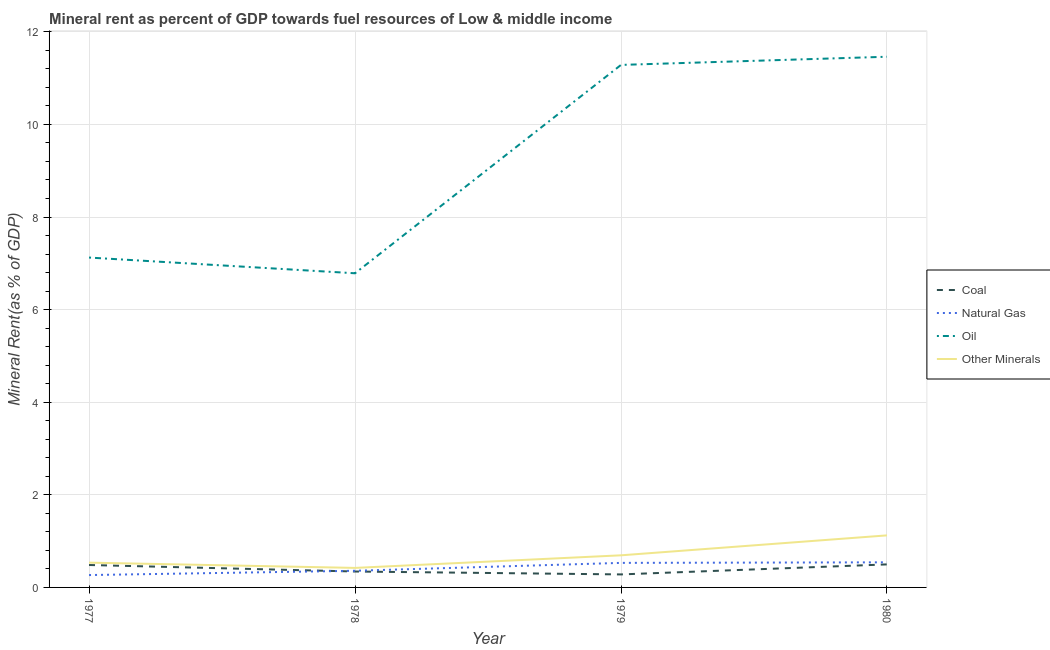How many different coloured lines are there?
Provide a short and direct response. 4. Does the line corresponding to coal rent intersect with the line corresponding to oil rent?
Your response must be concise. No. What is the natural gas rent in 1980?
Offer a very short reply. 0.54. Across all years, what is the maximum oil rent?
Your response must be concise. 11.46. Across all years, what is the minimum coal rent?
Give a very brief answer. 0.28. In which year was the coal rent minimum?
Ensure brevity in your answer.  1979. What is the total coal rent in the graph?
Your answer should be very brief. 1.61. What is the difference between the oil rent in 1977 and that in 1979?
Make the answer very short. -4.16. What is the difference between the coal rent in 1978 and the natural gas rent in 1977?
Give a very brief answer. 0.08. What is the average coal rent per year?
Your answer should be very brief. 0.4. In the year 1979, what is the difference between the natural gas rent and  rent of other minerals?
Ensure brevity in your answer.  -0.16. In how many years, is the natural gas rent greater than 0.4 %?
Offer a terse response. 2. What is the ratio of the coal rent in 1977 to that in 1978?
Give a very brief answer. 1.41. Is the difference between the oil rent in 1977 and 1979 greater than the difference between the natural gas rent in 1977 and 1979?
Make the answer very short. No. What is the difference between the highest and the second highest  rent of other minerals?
Offer a very short reply. 0.43. What is the difference between the highest and the lowest oil rent?
Make the answer very short. 4.68. In how many years, is the oil rent greater than the average oil rent taken over all years?
Offer a terse response. 2. Is it the case that in every year, the sum of the natural gas rent and  rent of other minerals is greater than the sum of coal rent and oil rent?
Make the answer very short. No. Does the  rent of other minerals monotonically increase over the years?
Ensure brevity in your answer.  No. Is the oil rent strictly greater than the coal rent over the years?
Keep it short and to the point. Yes. How many lines are there?
Provide a short and direct response. 4. How many years are there in the graph?
Offer a terse response. 4. Are the values on the major ticks of Y-axis written in scientific E-notation?
Provide a succinct answer. No. Does the graph contain grids?
Keep it short and to the point. Yes. What is the title of the graph?
Offer a very short reply. Mineral rent as percent of GDP towards fuel resources of Low & middle income. What is the label or title of the X-axis?
Offer a very short reply. Year. What is the label or title of the Y-axis?
Your response must be concise. Mineral Rent(as % of GDP). What is the Mineral Rent(as % of GDP) of Coal in 1977?
Give a very brief answer. 0.48. What is the Mineral Rent(as % of GDP) of Natural Gas in 1977?
Provide a short and direct response. 0.27. What is the Mineral Rent(as % of GDP) in Oil in 1977?
Your answer should be compact. 7.12. What is the Mineral Rent(as % of GDP) in Other Minerals in 1977?
Your response must be concise. 0.54. What is the Mineral Rent(as % of GDP) in Coal in 1978?
Your response must be concise. 0.34. What is the Mineral Rent(as % of GDP) in Natural Gas in 1978?
Offer a very short reply. 0.36. What is the Mineral Rent(as % of GDP) in Oil in 1978?
Your response must be concise. 6.79. What is the Mineral Rent(as % of GDP) of Other Minerals in 1978?
Your response must be concise. 0.42. What is the Mineral Rent(as % of GDP) of Coal in 1979?
Your response must be concise. 0.28. What is the Mineral Rent(as % of GDP) of Natural Gas in 1979?
Give a very brief answer. 0.53. What is the Mineral Rent(as % of GDP) in Oil in 1979?
Offer a terse response. 11.29. What is the Mineral Rent(as % of GDP) in Other Minerals in 1979?
Ensure brevity in your answer.  0.69. What is the Mineral Rent(as % of GDP) of Coal in 1980?
Your answer should be compact. 0.5. What is the Mineral Rent(as % of GDP) in Natural Gas in 1980?
Ensure brevity in your answer.  0.54. What is the Mineral Rent(as % of GDP) in Oil in 1980?
Offer a terse response. 11.46. What is the Mineral Rent(as % of GDP) of Other Minerals in 1980?
Provide a succinct answer. 1.12. Across all years, what is the maximum Mineral Rent(as % of GDP) in Coal?
Keep it short and to the point. 0.5. Across all years, what is the maximum Mineral Rent(as % of GDP) in Natural Gas?
Offer a very short reply. 0.54. Across all years, what is the maximum Mineral Rent(as % of GDP) of Oil?
Keep it short and to the point. 11.46. Across all years, what is the maximum Mineral Rent(as % of GDP) of Other Minerals?
Your response must be concise. 1.12. Across all years, what is the minimum Mineral Rent(as % of GDP) of Coal?
Your answer should be compact. 0.28. Across all years, what is the minimum Mineral Rent(as % of GDP) of Natural Gas?
Provide a short and direct response. 0.27. Across all years, what is the minimum Mineral Rent(as % of GDP) of Oil?
Offer a terse response. 6.79. Across all years, what is the minimum Mineral Rent(as % of GDP) of Other Minerals?
Give a very brief answer. 0.42. What is the total Mineral Rent(as % of GDP) in Coal in the graph?
Give a very brief answer. 1.61. What is the total Mineral Rent(as % of GDP) of Natural Gas in the graph?
Make the answer very short. 1.7. What is the total Mineral Rent(as % of GDP) of Oil in the graph?
Ensure brevity in your answer.  36.66. What is the total Mineral Rent(as % of GDP) in Other Minerals in the graph?
Offer a terse response. 2.77. What is the difference between the Mineral Rent(as % of GDP) of Coal in 1977 and that in 1978?
Keep it short and to the point. 0.14. What is the difference between the Mineral Rent(as % of GDP) of Natural Gas in 1977 and that in 1978?
Provide a short and direct response. -0.09. What is the difference between the Mineral Rent(as % of GDP) in Oil in 1977 and that in 1978?
Make the answer very short. 0.34. What is the difference between the Mineral Rent(as % of GDP) of Other Minerals in 1977 and that in 1978?
Your answer should be compact. 0.11. What is the difference between the Mineral Rent(as % of GDP) of Coal in 1977 and that in 1979?
Offer a terse response. 0.2. What is the difference between the Mineral Rent(as % of GDP) in Natural Gas in 1977 and that in 1979?
Make the answer very short. -0.26. What is the difference between the Mineral Rent(as % of GDP) of Oil in 1977 and that in 1979?
Ensure brevity in your answer.  -4.16. What is the difference between the Mineral Rent(as % of GDP) in Other Minerals in 1977 and that in 1979?
Offer a terse response. -0.16. What is the difference between the Mineral Rent(as % of GDP) in Coal in 1977 and that in 1980?
Provide a short and direct response. -0.01. What is the difference between the Mineral Rent(as % of GDP) of Natural Gas in 1977 and that in 1980?
Ensure brevity in your answer.  -0.28. What is the difference between the Mineral Rent(as % of GDP) of Oil in 1977 and that in 1980?
Keep it short and to the point. -4.34. What is the difference between the Mineral Rent(as % of GDP) of Other Minerals in 1977 and that in 1980?
Your answer should be compact. -0.59. What is the difference between the Mineral Rent(as % of GDP) in Coal in 1978 and that in 1979?
Offer a terse response. 0.06. What is the difference between the Mineral Rent(as % of GDP) in Natural Gas in 1978 and that in 1979?
Offer a very short reply. -0.17. What is the difference between the Mineral Rent(as % of GDP) in Oil in 1978 and that in 1979?
Ensure brevity in your answer.  -4.5. What is the difference between the Mineral Rent(as % of GDP) of Other Minerals in 1978 and that in 1979?
Keep it short and to the point. -0.27. What is the difference between the Mineral Rent(as % of GDP) of Coal in 1978 and that in 1980?
Keep it short and to the point. -0.15. What is the difference between the Mineral Rent(as % of GDP) of Natural Gas in 1978 and that in 1980?
Provide a short and direct response. -0.18. What is the difference between the Mineral Rent(as % of GDP) in Oil in 1978 and that in 1980?
Offer a terse response. -4.68. What is the difference between the Mineral Rent(as % of GDP) of Other Minerals in 1978 and that in 1980?
Provide a succinct answer. -0.7. What is the difference between the Mineral Rent(as % of GDP) in Coal in 1979 and that in 1980?
Your answer should be compact. -0.22. What is the difference between the Mineral Rent(as % of GDP) in Natural Gas in 1979 and that in 1980?
Make the answer very short. -0.01. What is the difference between the Mineral Rent(as % of GDP) of Oil in 1979 and that in 1980?
Give a very brief answer. -0.18. What is the difference between the Mineral Rent(as % of GDP) of Other Minerals in 1979 and that in 1980?
Your answer should be very brief. -0.43. What is the difference between the Mineral Rent(as % of GDP) of Coal in 1977 and the Mineral Rent(as % of GDP) of Natural Gas in 1978?
Your response must be concise. 0.13. What is the difference between the Mineral Rent(as % of GDP) of Coal in 1977 and the Mineral Rent(as % of GDP) of Oil in 1978?
Offer a terse response. -6.3. What is the difference between the Mineral Rent(as % of GDP) in Coal in 1977 and the Mineral Rent(as % of GDP) in Other Minerals in 1978?
Give a very brief answer. 0.06. What is the difference between the Mineral Rent(as % of GDP) of Natural Gas in 1977 and the Mineral Rent(as % of GDP) of Oil in 1978?
Your response must be concise. -6.52. What is the difference between the Mineral Rent(as % of GDP) in Natural Gas in 1977 and the Mineral Rent(as % of GDP) in Other Minerals in 1978?
Give a very brief answer. -0.15. What is the difference between the Mineral Rent(as % of GDP) in Oil in 1977 and the Mineral Rent(as % of GDP) in Other Minerals in 1978?
Your answer should be very brief. 6.7. What is the difference between the Mineral Rent(as % of GDP) in Coal in 1977 and the Mineral Rent(as % of GDP) in Natural Gas in 1979?
Your response must be concise. -0.05. What is the difference between the Mineral Rent(as % of GDP) in Coal in 1977 and the Mineral Rent(as % of GDP) in Oil in 1979?
Give a very brief answer. -10.8. What is the difference between the Mineral Rent(as % of GDP) in Coal in 1977 and the Mineral Rent(as % of GDP) in Other Minerals in 1979?
Provide a short and direct response. -0.21. What is the difference between the Mineral Rent(as % of GDP) of Natural Gas in 1977 and the Mineral Rent(as % of GDP) of Oil in 1979?
Your answer should be compact. -11.02. What is the difference between the Mineral Rent(as % of GDP) of Natural Gas in 1977 and the Mineral Rent(as % of GDP) of Other Minerals in 1979?
Your answer should be very brief. -0.43. What is the difference between the Mineral Rent(as % of GDP) in Oil in 1977 and the Mineral Rent(as % of GDP) in Other Minerals in 1979?
Offer a terse response. 6.43. What is the difference between the Mineral Rent(as % of GDP) in Coal in 1977 and the Mineral Rent(as % of GDP) in Natural Gas in 1980?
Give a very brief answer. -0.06. What is the difference between the Mineral Rent(as % of GDP) in Coal in 1977 and the Mineral Rent(as % of GDP) in Oil in 1980?
Make the answer very short. -10.98. What is the difference between the Mineral Rent(as % of GDP) in Coal in 1977 and the Mineral Rent(as % of GDP) in Other Minerals in 1980?
Your answer should be compact. -0.64. What is the difference between the Mineral Rent(as % of GDP) in Natural Gas in 1977 and the Mineral Rent(as % of GDP) in Oil in 1980?
Provide a short and direct response. -11.19. What is the difference between the Mineral Rent(as % of GDP) in Natural Gas in 1977 and the Mineral Rent(as % of GDP) in Other Minerals in 1980?
Your answer should be compact. -0.86. What is the difference between the Mineral Rent(as % of GDP) in Oil in 1977 and the Mineral Rent(as % of GDP) in Other Minerals in 1980?
Give a very brief answer. 6. What is the difference between the Mineral Rent(as % of GDP) in Coal in 1978 and the Mineral Rent(as % of GDP) in Natural Gas in 1979?
Offer a very short reply. -0.19. What is the difference between the Mineral Rent(as % of GDP) of Coal in 1978 and the Mineral Rent(as % of GDP) of Oil in 1979?
Your answer should be compact. -10.94. What is the difference between the Mineral Rent(as % of GDP) of Coal in 1978 and the Mineral Rent(as % of GDP) of Other Minerals in 1979?
Provide a succinct answer. -0.35. What is the difference between the Mineral Rent(as % of GDP) of Natural Gas in 1978 and the Mineral Rent(as % of GDP) of Oil in 1979?
Give a very brief answer. -10.93. What is the difference between the Mineral Rent(as % of GDP) of Natural Gas in 1978 and the Mineral Rent(as % of GDP) of Other Minerals in 1979?
Ensure brevity in your answer.  -0.33. What is the difference between the Mineral Rent(as % of GDP) in Oil in 1978 and the Mineral Rent(as % of GDP) in Other Minerals in 1979?
Your answer should be compact. 6.09. What is the difference between the Mineral Rent(as % of GDP) of Coal in 1978 and the Mineral Rent(as % of GDP) of Natural Gas in 1980?
Ensure brevity in your answer.  -0.2. What is the difference between the Mineral Rent(as % of GDP) of Coal in 1978 and the Mineral Rent(as % of GDP) of Oil in 1980?
Give a very brief answer. -11.12. What is the difference between the Mineral Rent(as % of GDP) in Coal in 1978 and the Mineral Rent(as % of GDP) in Other Minerals in 1980?
Give a very brief answer. -0.78. What is the difference between the Mineral Rent(as % of GDP) in Natural Gas in 1978 and the Mineral Rent(as % of GDP) in Oil in 1980?
Offer a terse response. -11.1. What is the difference between the Mineral Rent(as % of GDP) in Natural Gas in 1978 and the Mineral Rent(as % of GDP) in Other Minerals in 1980?
Your response must be concise. -0.76. What is the difference between the Mineral Rent(as % of GDP) in Oil in 1978 and the Mineral Rent(as % of GDP) in Other Minerals in 1980?
Your answer should be compact. 5.66. What is the difference between the Mineral Rent(as % of GDP) of Coal in 1979 and the Mineral Rent(as % of GDP) of Natural Gas in 1980?
Offer a terse response. -0.26. What is the difference between the Mineral Rent(as % of GDP) of Coal in 1979 and the Mineral Rent(as % of GDP) of Oil in 1980?
Offer a terse response. -11.18. What is the difference between the Mineral Rent(as % of GDP) in Coal in 1979 and the Mineral Rent(as % of GDP) in Other Minerals in 1980?
Your response must be concise. -0.84. What is the difference between the Mineral Rent(as % of GDP) in Natural Gas in 1979 and the Mineral Rent(as % of GDP) in Oil in 1980?
Make the answer very short. -10.93. What is the difference between the Mineral Rent(as % of GDP) of Natural Gas in 1979 and the Mineral Rent(as % of GDP) of Other Minerals in 1980?
Offer a terse response. -0.59. What is the difference between the Mineral Rent(as % of GDP) in Oil in 1979 and the Mineral Rent(as % of GDP) in Other Minerals in 1980?
Offer a very short reply. 10.16. What is the average Mineral Rent(as % of GDP) of Coal per year?
Your answer should be compact. 0.4. What is the average Mineral Rent(as % of GDP) in Natural Gas per year?
Make the answer very short. 0.42. What is the average Mineral Rent(as % of GDP) of Oil per year?
Your answer should be very brief. 9.16. What is the average Mineral Rent(as % of GDP) of Other Minerals per year?
Your answer should be very brief. 0.69. In the year 1977, what is the difference between the Mineral Rent(as % of GDP) in Coal and Mineral Rent(as % of GDP) in Natural Gas?
Provide a succinct answer. 0.22. In the year 1977, what is the difference between the Mineral Rent(as % of GDP) in Coal and Mineral Rent(as % of GDP) in Oil?
Give a very brief answer. -6.64. In the year 1977, what is the difference between the Mineral Rent(as % of GDP) in Coal and Mineral Rent(as % of GDP) in Other Minerals?
Your answer should be very brief. -0.05. In the year 1977, what is the difference between the Mineral Rent(as % of GDP) of Natural Gas and Mineral Rent(as % of GDP) of Oil?
Offer a very short reply. -6.86. In the year 1977, what is the difference between the Mineral Rent(as % of GDP) in Natural Gas and Mineral Rent(as % of GDP) in Other Minerals?
Ensure brevity in your answer.  -0.27. In the year 1977, what is the difference between the Mineral Rent(as % of GDP) in Oil and Mineral Rent(as % of GDP) in Other Minerals?
Keep it short and to the point. 6.59. In the year 1978, what is the difference between the Mineral Rent(as % of GDP) of Coal and Mineral Rent(as % of GDP) of Natural Gas?
Your answer should be very brief. -0.02. In the year 1978, what is the difference between the Mineral Rent(as % of GDP) of Coal and Mineral Rent(as % of GDP) of Oil?
Provide a short and direct response. -6.44. In the year 1978, what is the difference between the Mineral Rent(as % of GDP) of Coal and Mineral Rent(as % of GDP) of Other Minerals?
Offer a terse response. -0.08. In the year 1978, what is the difference between the Mineral Rent(as % of GDP) of Natural Gas and Mineral Rent(as % of GDP) of Oil?
Your response must be concise. -6.43. In the year 1978, what is the difference between the Mineral Rent(as % of GDP) of Natural Gas and Mineral Rent(as % of GDP) of Other Minerals?
Give a very brief answer. -0.06. In the year 1978, what is the difference between the Mineral Rent(as % of GDP) of Oil and Mineral Rent(as % of GDP) of Other Minerals?
Keep it short and to the point. 6.36. In the year 1979, what is the difference between the Mineral Rent(as % of GDP) of Coal and Mineral Rent(as % of GDP) of Natural Gas?
Make the answer very short. -0.25. In the year 1979, what is the difference between the Mineral Rent(as % of GDP) of Coal and Mineral Rent(as % of GDP) of Oil?
Provide a succinct answer. -11. In the year 1979, what is the difference between the Mineral Rent(as % of GDP) in Coal and Mineral Rent(as % of GDP) in Other Minerals?
Provide a short and direct response. -0.41. In the year 1979, what is the difference between the Mineral Rent(as % of GDP) of Natural Gas and Mineral Rent(as % of GDP) of Oil?
Make the answer very short. -10.76. In the year 1979, what is the difference between the Mineral Rent(as % of GDP) of Natural Gas and Mineral Rent(as % of GDP) of Other Minerals?
Your answer should be compact. -0.16. In the year 1979, what is the difference between the Mineral Rent(as % of GDP) of Oil and Mineral Rent(as % of GDP) of Other Minerals?
Keep it short and to the point. 10.59. In the year 1980, what is the difference between the Mineral Rent(as % of GDP) in Coal and Mineral Rent(as % of GDP) in Natural Gas?
Your answer should be very brief. -0.04. In the year 1980, what is the difference between the Mineral Rent(as % of GDP) in Coal and Mineral Rent(as % of GDP) in Oil?
Provide a succinct answer. -10.96. In the year 1980, what is the difference between the Mineral Rent(as % of GDP) in Coal and Mineral Rent(as % of GDP) in Other Minerals?
Keep it short and to the point. -0.63. In the year 1980, what is the difference between the Mineral Rent(as % of GDP) in Natural Gas and Mineral Rent(as % of GDP) in Oil?
Ensure brevity in your answer.  -10.92. In the year 1980, what is the difference between the Mineral Rent(as % of GDP) in Natural Gas and Mineral Rent(as % of GDP) in Other Minerals?
Your answer should be very brief. -0.58. In the year 1980, what is the difference between the Mineral Rent(as % of GDP) in Oil and Mineral Rent(as % of GDP) in Other Minerals?
Offer a very short reply. 10.34. What is the ratio of the Mineral Rent(as % of GDP) of Coal in 1977 to that in 1978?
Give a very brief answer. 1.41. What is the ratio of the Mineral Rent(as % of GDP) in Natural Gas in 1977 to that in 1978?
Your answer should be very brief. 0.74. What is the ratio of the Mineral Rent(as % of GDP) in Oil in 1977 to that in 1978?
Your answer should be very brief. 1.05. What is the ratio of the Mineral Rent(as % of GDP) in Other Minerals in 1977 to that in 1978?
Give a very brief answer. 1.27. What is the ratio of the Mineral Rent(as % of GDP) in Coal in 1977 to that in 1979?
Offer a very short reply. 1.72. What is the ratio of the Mineral Rent(as % of GDP) of Natural Gas in 1977 to that in 1979?
Offer a very short reply. 0.5. What is the ratio of the Mineral Rent(as % of GDP) of Oil in 1977 to that in 1979?
Offer a very short reply. 0.63. What is the ratio of the Mineral Rent(as % of GDP) in Other Minerals in 1977 to that in 1979?
Make the answer very short. 0.77. What is the ratio of the Mineral Rent(as % of GDP) in Coal in 1977 to that in 1980?
Your answer should be very brief. 0.97. What is the ratio of the Mineral Rent(as % of GDP) in Natural Gas in 1977 to that in 1980?
Give a very brief answer. 0.49. What is the ratio of the Mineral Rent(as % of GDP) of Oil in 1977 to that in 1980?
Give a very brief answer. 0.62. What is the ratio of the Mineral Rent(as % of GDP) of Other Minerals in 1977 to that in 1980?
Provide a succinct answer. 0.48. What is the ratio of the Mineral Rent(as % of GDP) of Coal in 1978 to that in 1979?
Give a very brief answer. 1.22. What is the ratio of the Mineral Rent(as % of GDP) in Natural Gas in 1978 to that in 1979?
Ensure brevity in your answer.  0.68. What is the ratio of the Mineral Rent(as % of GDP) of Oil in 1978 to that in 1979?
Offer a very short reply. 0.6. What is the ratio of the Mineral Rent(as % of GDP) of Other Minerals in 1978 to that in 1979?
Provide a short and direct response. 0.61. What is the ratio of the Mineral Rent(as % of GDP) of Coal in 1978 to that in 1980?
Keep it short and to the point. 0.69. What is the ratio of the Mineral Rent(as % of GDP) of Natural Gas in 1978 to that in 1980?
Offer a very short reply. 0.66. What is the ratio of the Mineral Rent(as % of GDP) in Oil in 1978 to that in 1980?
Make the answer very short. 0.59. What is the ratio of the Mineral Rent(as % of GDP) in Other Minerals in 1978 to that in 1980?
Your answer should be very brief. 0.37. What is the ratio of the Mineral Rent(as % of GDP) in Coal in 1979 to that in 1980?
Make the answer very short. 0.56. What is the ratio of the Mineral Rent(as % of GDP) in Natural Gas in 1979 to that in 1980?
Your response must be concise. 0.98. What is the ratio of the Mineral Rent(as % of GDP) of Oil in 1979 to that in 1980?
Provide a succinct answer. 0.98. What is the ratio of the Mineral Rent(as % of GDP) of Other Minerals in 1979 to that in 1980?
Provide a short and direct response. 0.62. What is the difference between the highest and the second highest Mineral Rent(as % of GDP) in Coal?
Offer a terse response. 0.01. What is the difference between the highest and the second highest Mineral Rent(as % of GDP) in Natural Gas?
Give a very brief answer. 0.01. What is the difference between the highest and the second highest Mineral Rent(as % of GDP) in Oil?
Give a very brief answer. 0.18. What is the difference between the highest and the second highest Mineral Rent(as % of GDP) of Other Minerals?
Your answer should be compact. 0.43. What is the difference between the highest and the lowest Mineral Rent(as % of GDP) of Coal?
Your answer should be very brief. 0.22. What is the difference between the highest and the lowest Mineral Rent(as % of GDP) in Natural Gas?
Provide a short and direct response. 0.28. What is the difference between the highest and the lowest Mineral Rent(as % of GDP) of Oil?
Make the answer very short. 4.68. What is the difference between the highest and the lowest Mineral Rent(as % of GDP) in Other Minerals?
Make the answer very short. 0.7. 